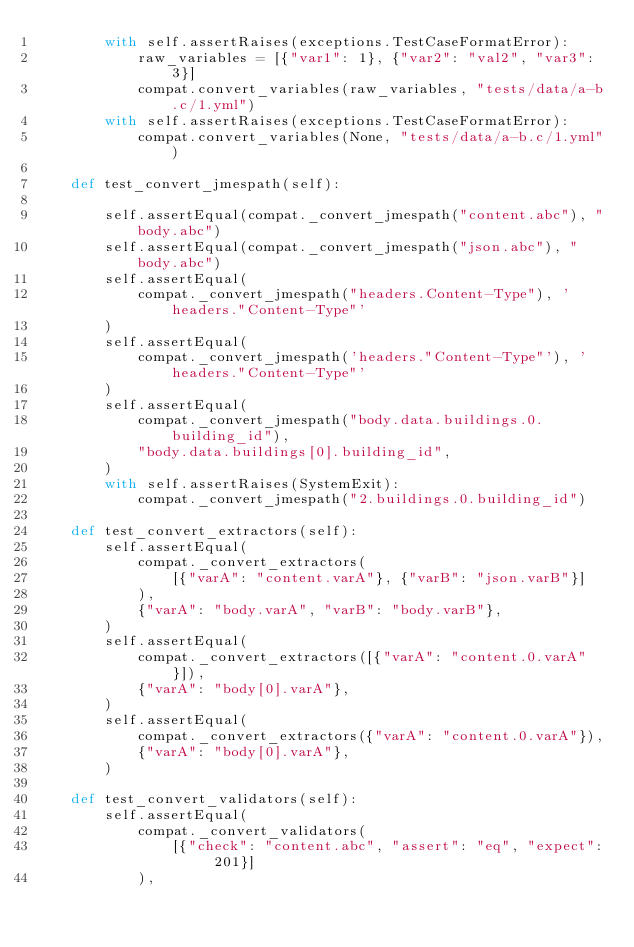Convert code to text. <code><loc_0><loc_0><loc_500><loc_500><_Python_>        with self.assertRaises(exceptions.TestCaseFormatError):
            raw_variables = [{"var1": 1}, {"var2": "val2", "var3": 3}]
            compat.convert_variables(raw_variables, "tests/data/a-b.c/1.yml")
        with self.assertRaises(exceptions.TestCaseFormatError):
            compat.convert_variables(None, "tests/data/a-b.c/1.yml")

    def test_convert_jmespath(self):

        self.assertEqual(compat._convert_jmespath("content.abc"), "body.abc")
        self.assertEqual(compat._convert_jmespath("json.abc"), "body.abc")
        self.assertEqual(
            compat._convert_jmespath("headers.Content-Type"), 'headers."Content-Type"'
        )
        self.assertEqual(
            compat._convert_jmespath('headers."Content-Type"'), 'headers."Content-Type"'
        )
        self.assertEqual(
            compat._convert_jmespath("body.data.buildings.0.building_id"),
            "body.data.buildings[0].building_id",
        )
        with self.assertRaises(SystemExit):
            compat._convert_jmespath("2.buildings.0.building_id")

    def test_convert_extractors(self):
        self.assertEqual(
            compat._convert_extractors(
                [{"varA": "content.varA"}, {"varB": "json.varB"}]
            ),
            {"varA": "body.varA", "varB": "body.varB"},
        )
        self.assertEqual(
            compat._convert_extractors([{"varA": "content.0.varA"}]),
            {"varA": "body[0].varA"},
        )
        self.assertEqual(
            compat._convert_extractors({"varA": "content.0.varA"}),
            {"varA": "body[0].varA"},
        )

    def test_convert_validators(self):
        self.assertEqual(
            compat._convert_validators(
                [{"check": "content.abc", "assert": "eq", "expect": 201}]
            ),</code> 